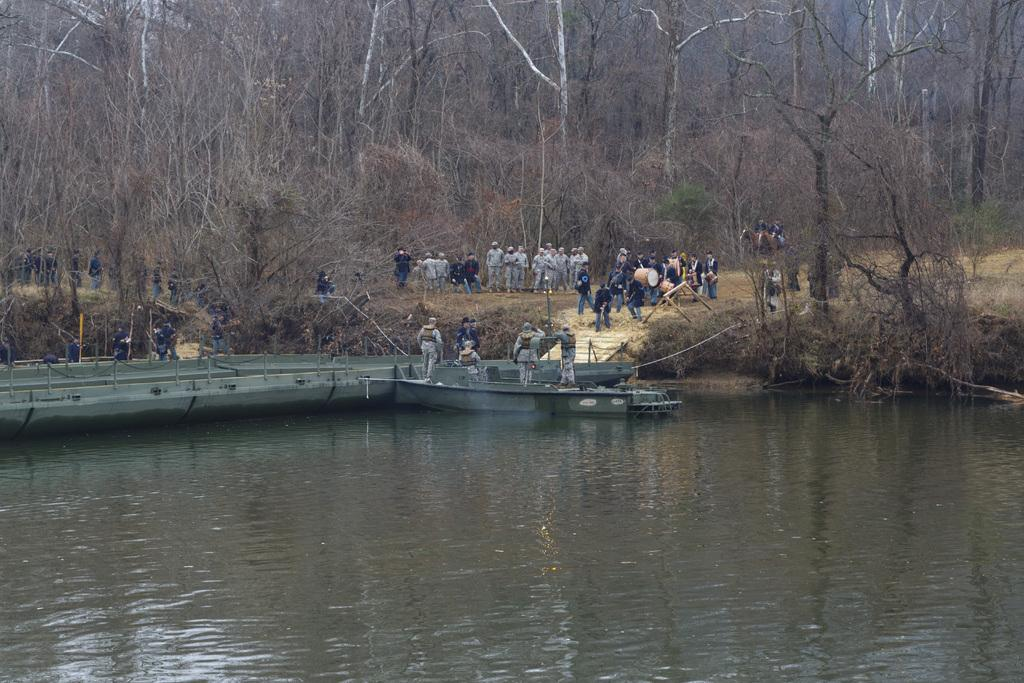What is the main subject in the foreground of the image? There is a water surface in the foreground of the image. What are the people in the image doing? There are people on a boat and people walking in the image. What can be seen in the background of the image? There are trees in the background of the image. What type of force is being applied to the water by the people walking in the image? There is no indication in the image that the people walking are applying any force to the water. 